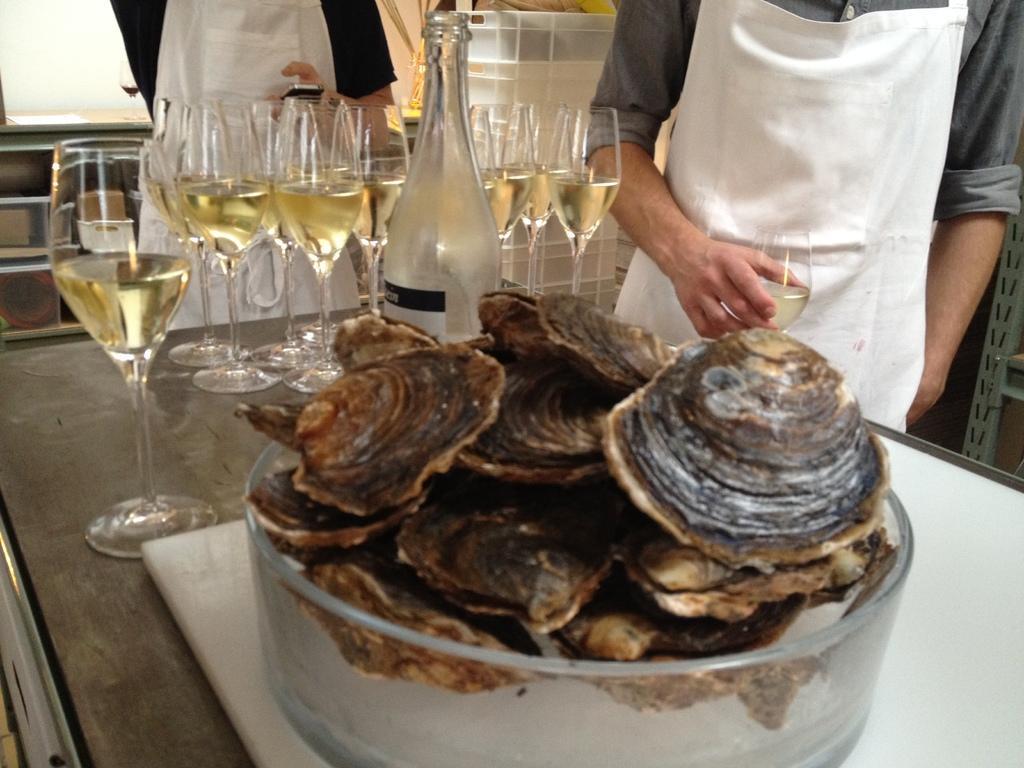In one or two sentences, can you explain what this image depicts? In this image, we can see some food item in a container is placed on the white surface. We can also see some glasses with liquid and also a bottle. There are a few people. We can also see the wall and a table with some objects. We can also see a white colored object and an object on the right. 